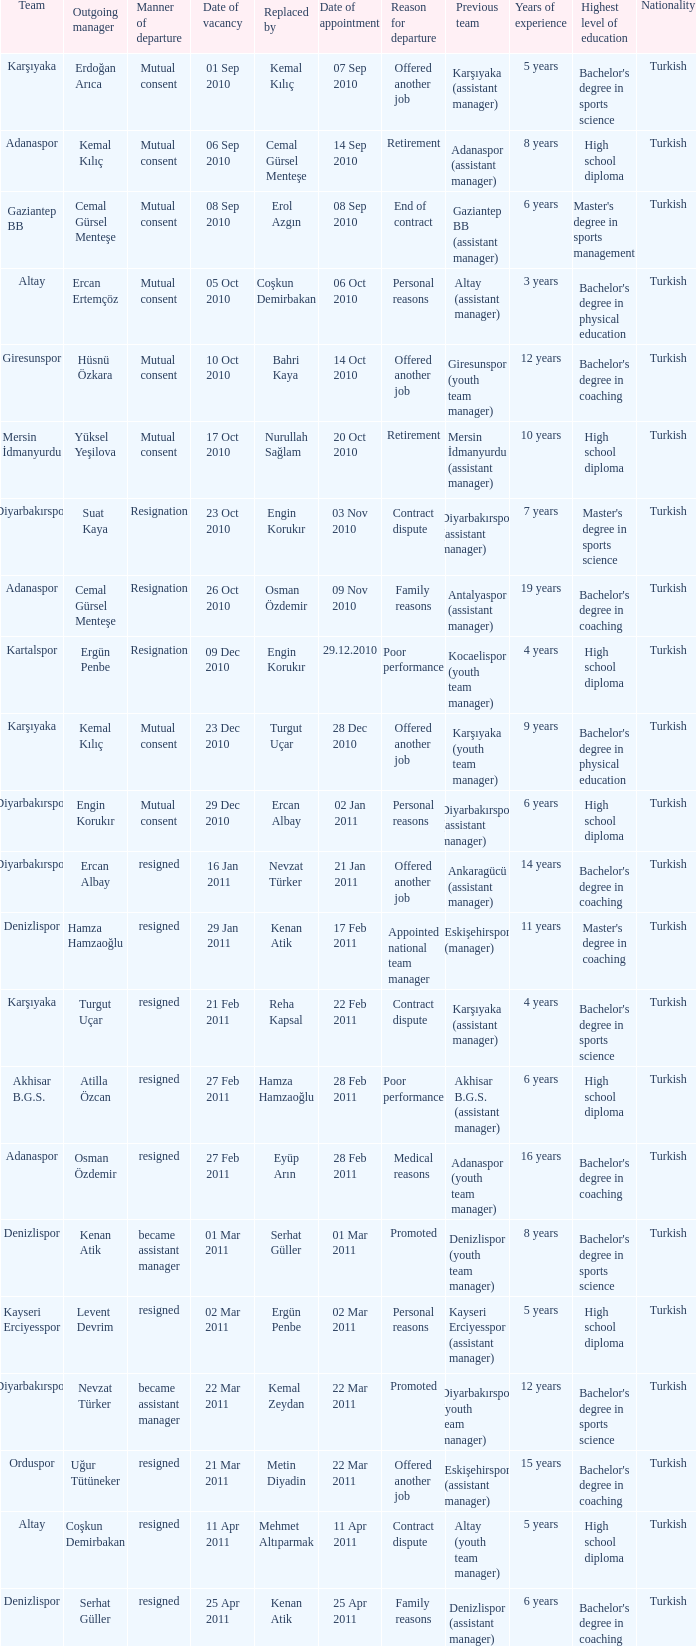Who replaced the manager of Akhisar B.G.S.? Hamza Hamzaoğlu. 